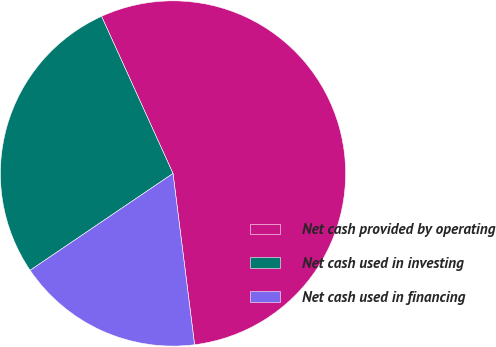Convert chart to OTSL. <chart><loc_0><loc_0><loc_500><loc_500><pie_chart><fcel>Net cash provided by operating<fcel>Net cash used in investing<fcel>Net cash used in financing<nl><fcel>54.8%<fcel>27.69%<fcel>17.51%<nl></chart> 